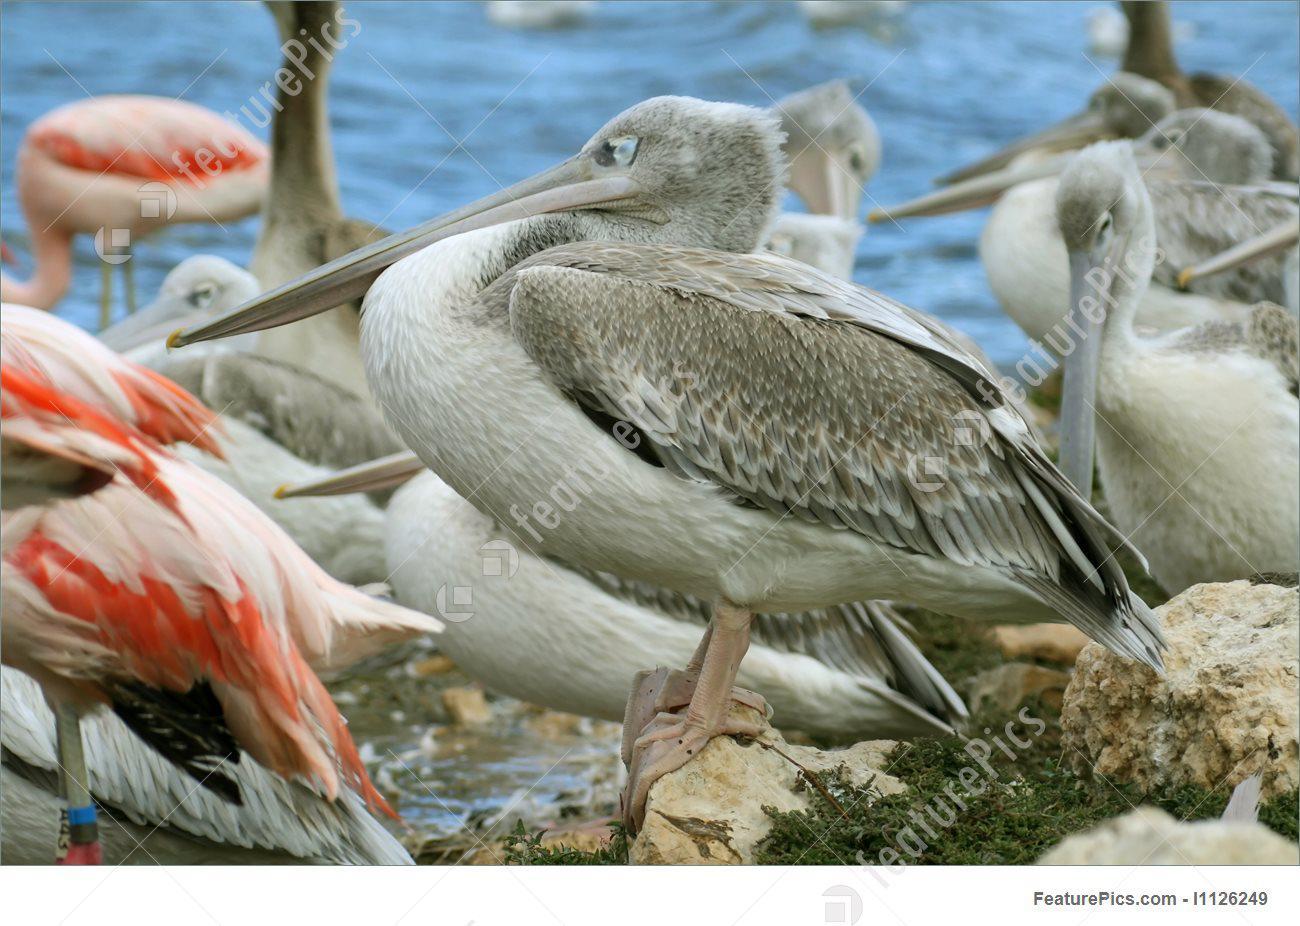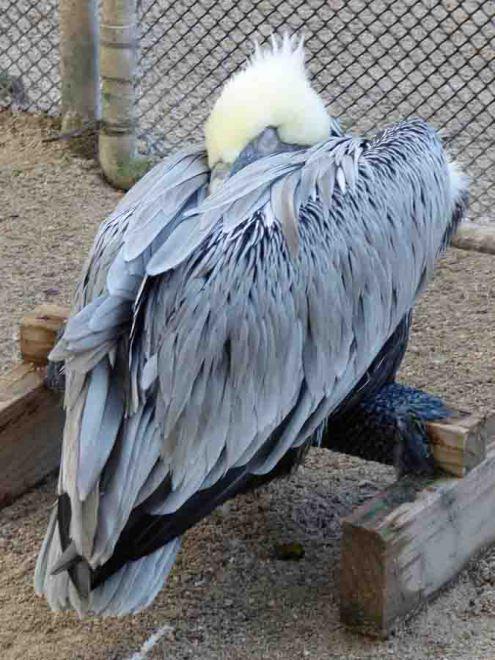The first image is the image on the left, the second image is the image on the right. For the images displayed, is the sentence "Each image contains exactly one pelican, and all pelicans have a flattened pose with bill resting on breast." factually correct? Answer yes or no. No. 